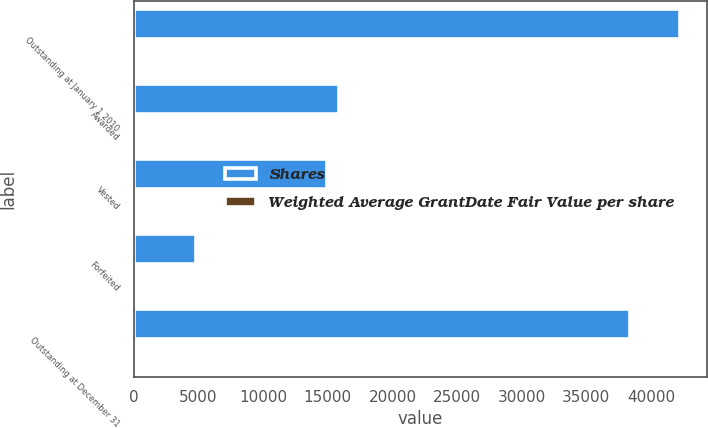Convert chart. <chart><loc_0><loc_0><loc_500><loc_500><stacked_bar_chart><ecel><fcel>Outstanding at January 1 2010<fcel>Awarded<fcel>Vested<fcel>Forfeited<fcel>Outstanding at December 31<nl><fcel>Shares<fcel>42241<fcel>15843<fcel>14920<fcel>4816<fcel>38348<nl><fcel>Weighted Average GrantDate Fair Value per share<fcel>18.13<fcel>24.12<fcel>20.28<fcel>19.7<fcel>19.55<nl></chart> 